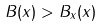Convert formula to latex. <formula><loc_0><loc_0><loc_500><loc_500>B ( x ) > B _ { x } ( x )</formula> 